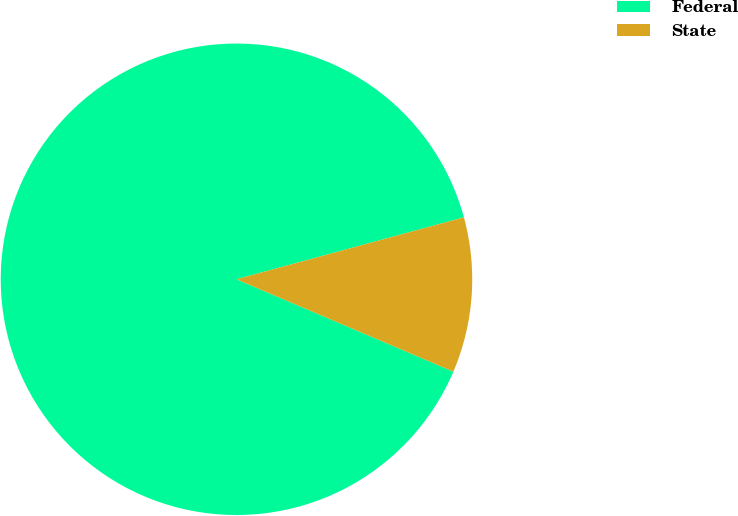<chart> <loc_0><loc_0><loc_500><loc_500><pie_chart><fcel>Federal<fcel>State<nl><fcel>89.36%<fcel>10.64%<nl></chart> 